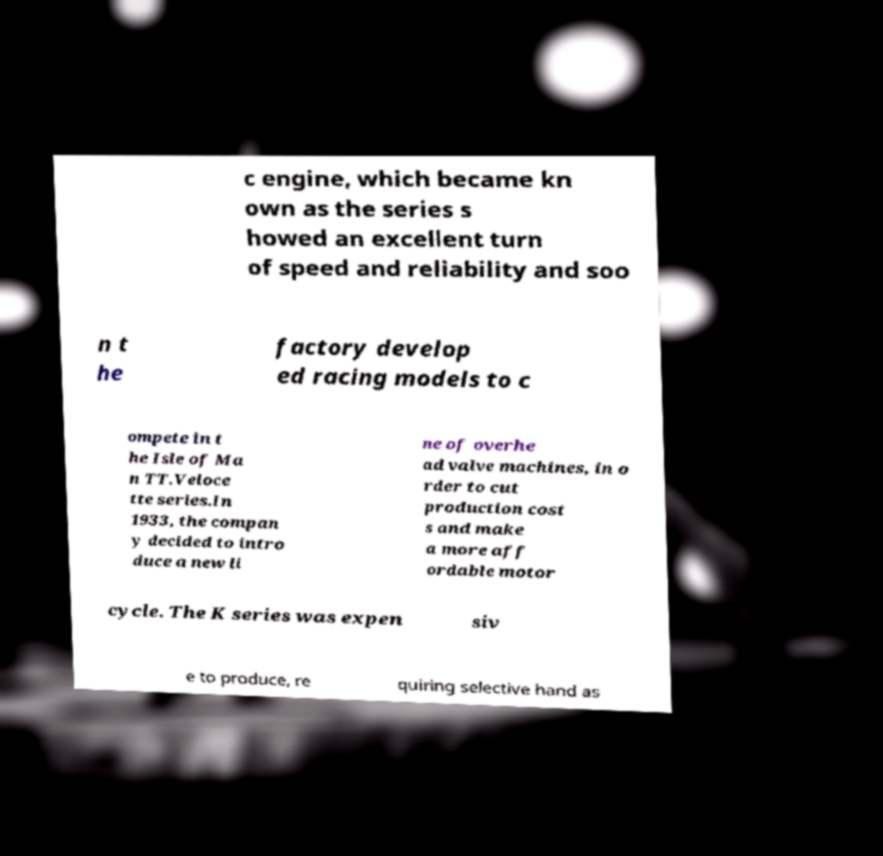I need the written content from this picture converted into text. Can you do that? c engine, which became kn own as the series s howed an excellent turn of speed and reliability and soo n t he factory develop ed racing models to c ompete in t he Isle of Ma n TT.Veloce tte series.In 1933, the compan y decided to intro duce a new li ne of overhe ad valve machines, in o rder to cut production cost s and make a more aff ordable motor cycle. The K series was expen siv e to produce, re quiring selective hand as 